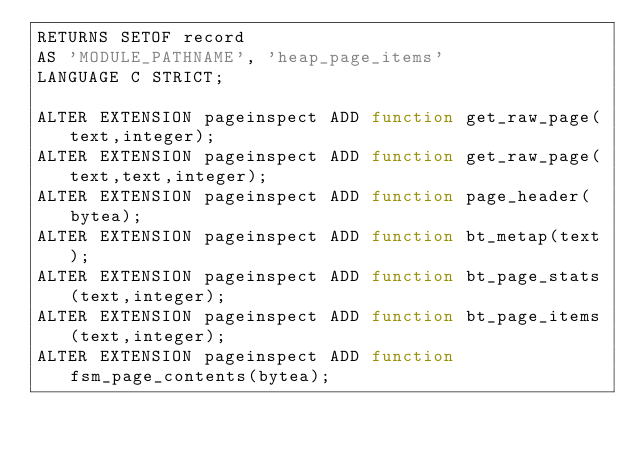Convert code to text. <code><loc_0><loc_0><loc_500><loc_500><_SQL_>RETURNS SETOF record
AS 'MODULE_PATHNAME', 'heap_page_items'
LANGUAGE C STRICT;

ALTER EXTENSION pageinspect ADD function get_raw_page(text,integer);
ALTER EXTENSION pageinspect ADD function get_raw_page(text,text,integer);
ALTER EXTENSION pageinspect ADD function page_header(bytea);
ALTER EXTENSION pageinspect ADD function bt_metap(text);
ALTER EXTENSION pageinspect ADD function bt_page_stats(text,integer);
ALTER EXTENSION pageinspect ADD function bt_page_items(text,integer);
ALTER EXTENSION pageinspect ADD function fsm_page_contents(bytea);
</code> 